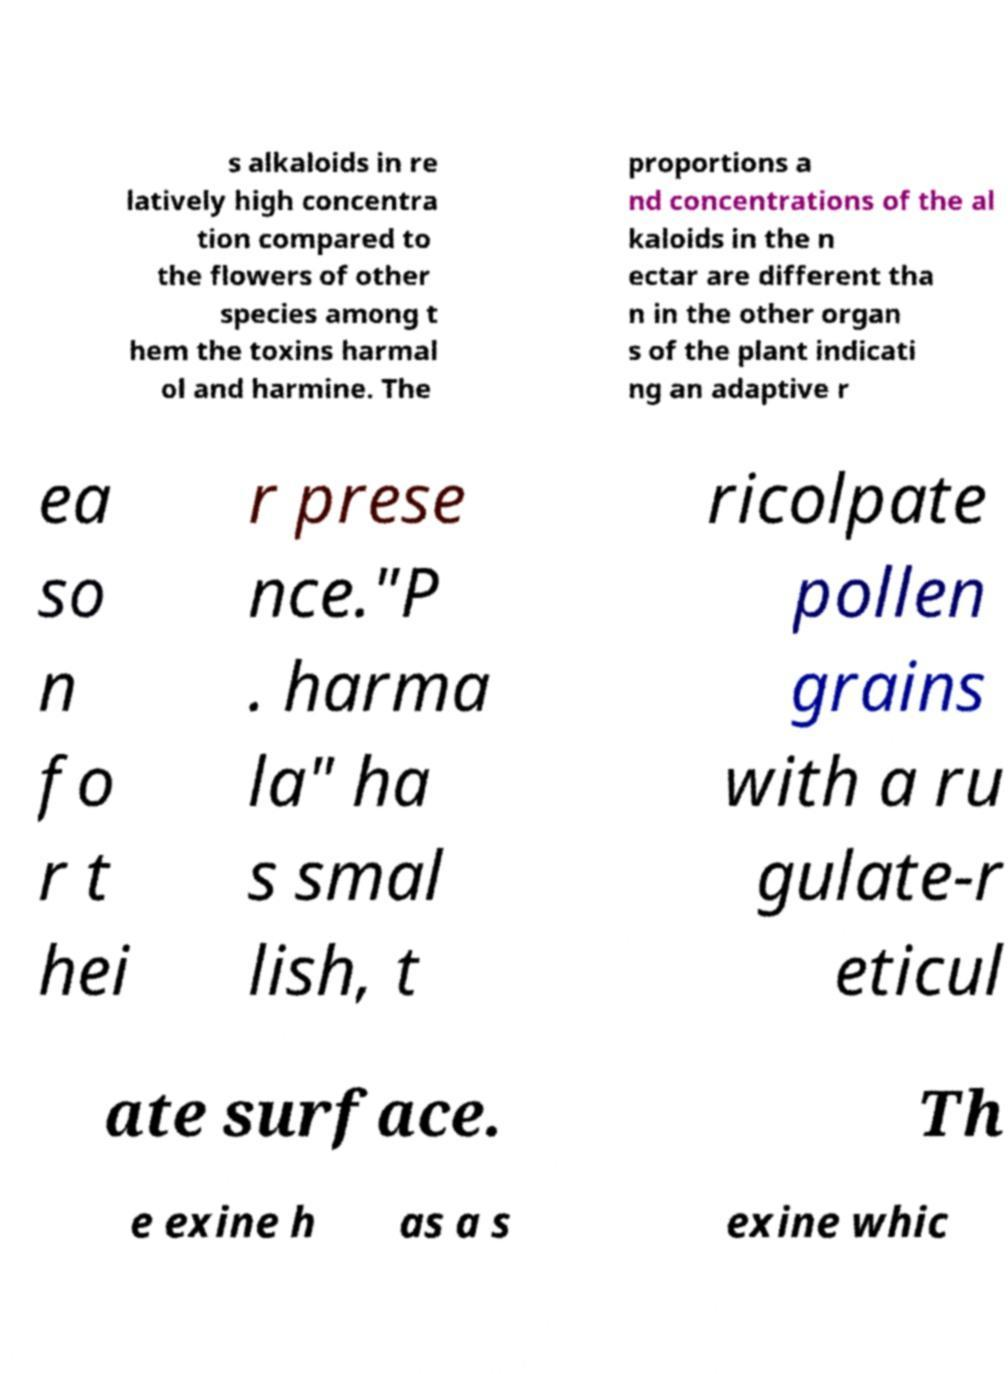Could you extract and type out the text from this image? s alkaloids in re latively high concentra tion compared to the flowers of other species among t hem the toxins harmal ol and harmine. The proportions a nd concentrations of the al kaloids in the n ectar are different tha n in the other organ s of the plant indicati ng an adaptive r ea so n fo r t hei r prese nce."P . harma la" ha s smal lish, t ricolpate pollen grains with a ru gulate-r eticul ate surface. Th e exine h as a s exine whic 